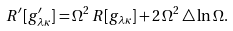Convert formula to latex. <formula><loc_0><loc_0><loc_500><loc_500>R ^ { \prime } [ g ^ { \prime } _ { \lambda \kappa } ] = \Omega ^ { 2 } \, R [ g _ { \lambda \kappa } ] + 2 \, \Omega ^ { 2 } \, \triangle \ln \Omega .</formula> 